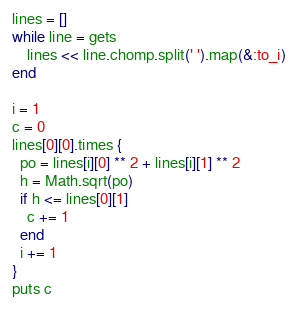Convert code to text. <code><loc_0><loc_0><loc_500><loc_500><_Ruby_>lines = []
while line = gets
    lines << line.chomp.split(' ').map(&:to_i)
end

i = 1
c = 0
lines[0][0].times {
  po = lines[i][0] ** 2 + lines[i][1] ** 2
  h = Math.sqrt(po)
  if h <= lines[0][1]
  	c += 1
  end
  i += 1
}
puts c
</code> 